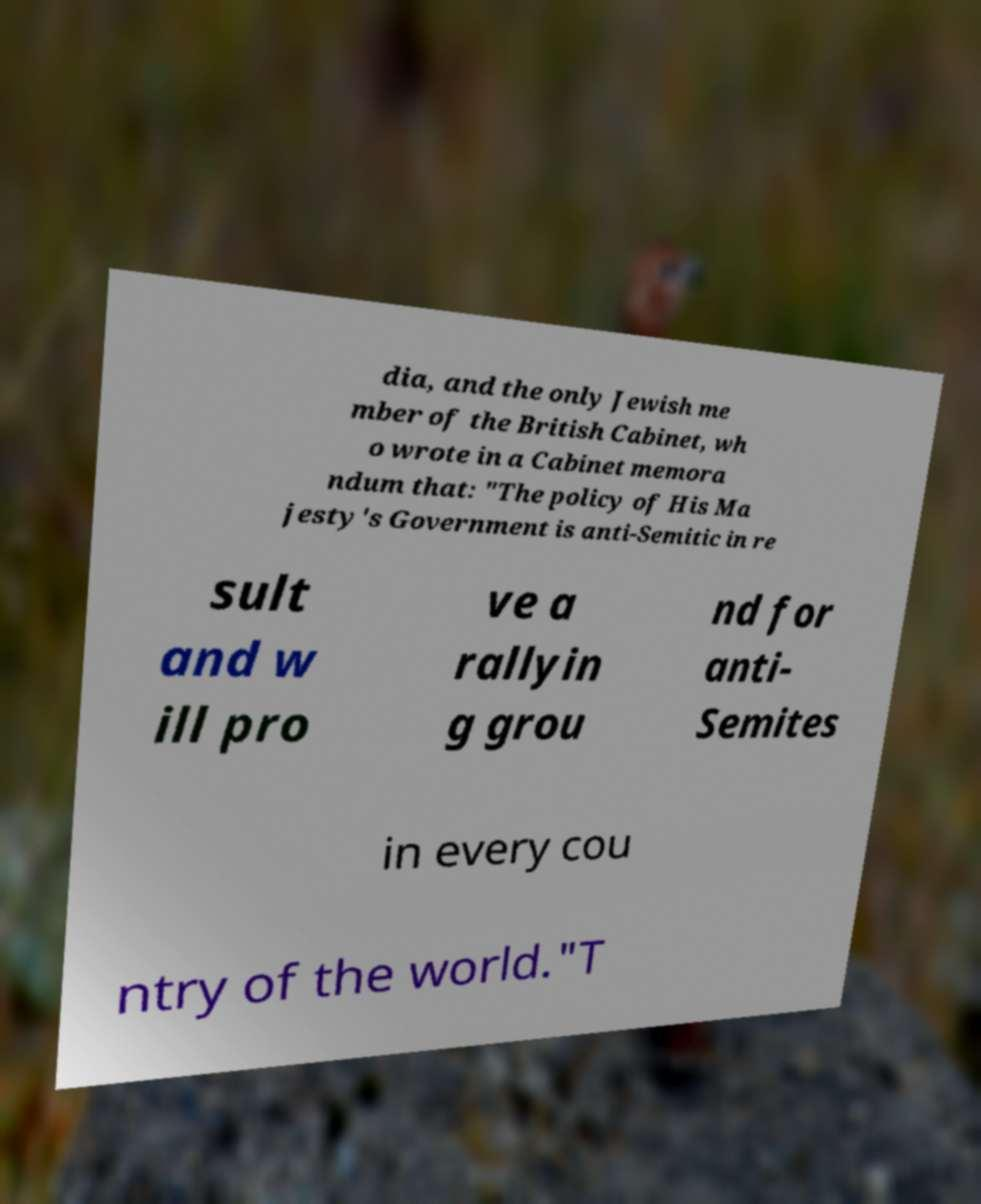I need the written content from this picture converted into text. Can you do that? dia, and the only Jewish me mber of the British Cabinet, wh o wrote in a Cabinet memora ndum that: "The policy of His Ma jesty's Government is anti-Semitic in re sult and w ill pro ve a rallyin g grou nd for anti- Semites in every cou ntry of the world."T 